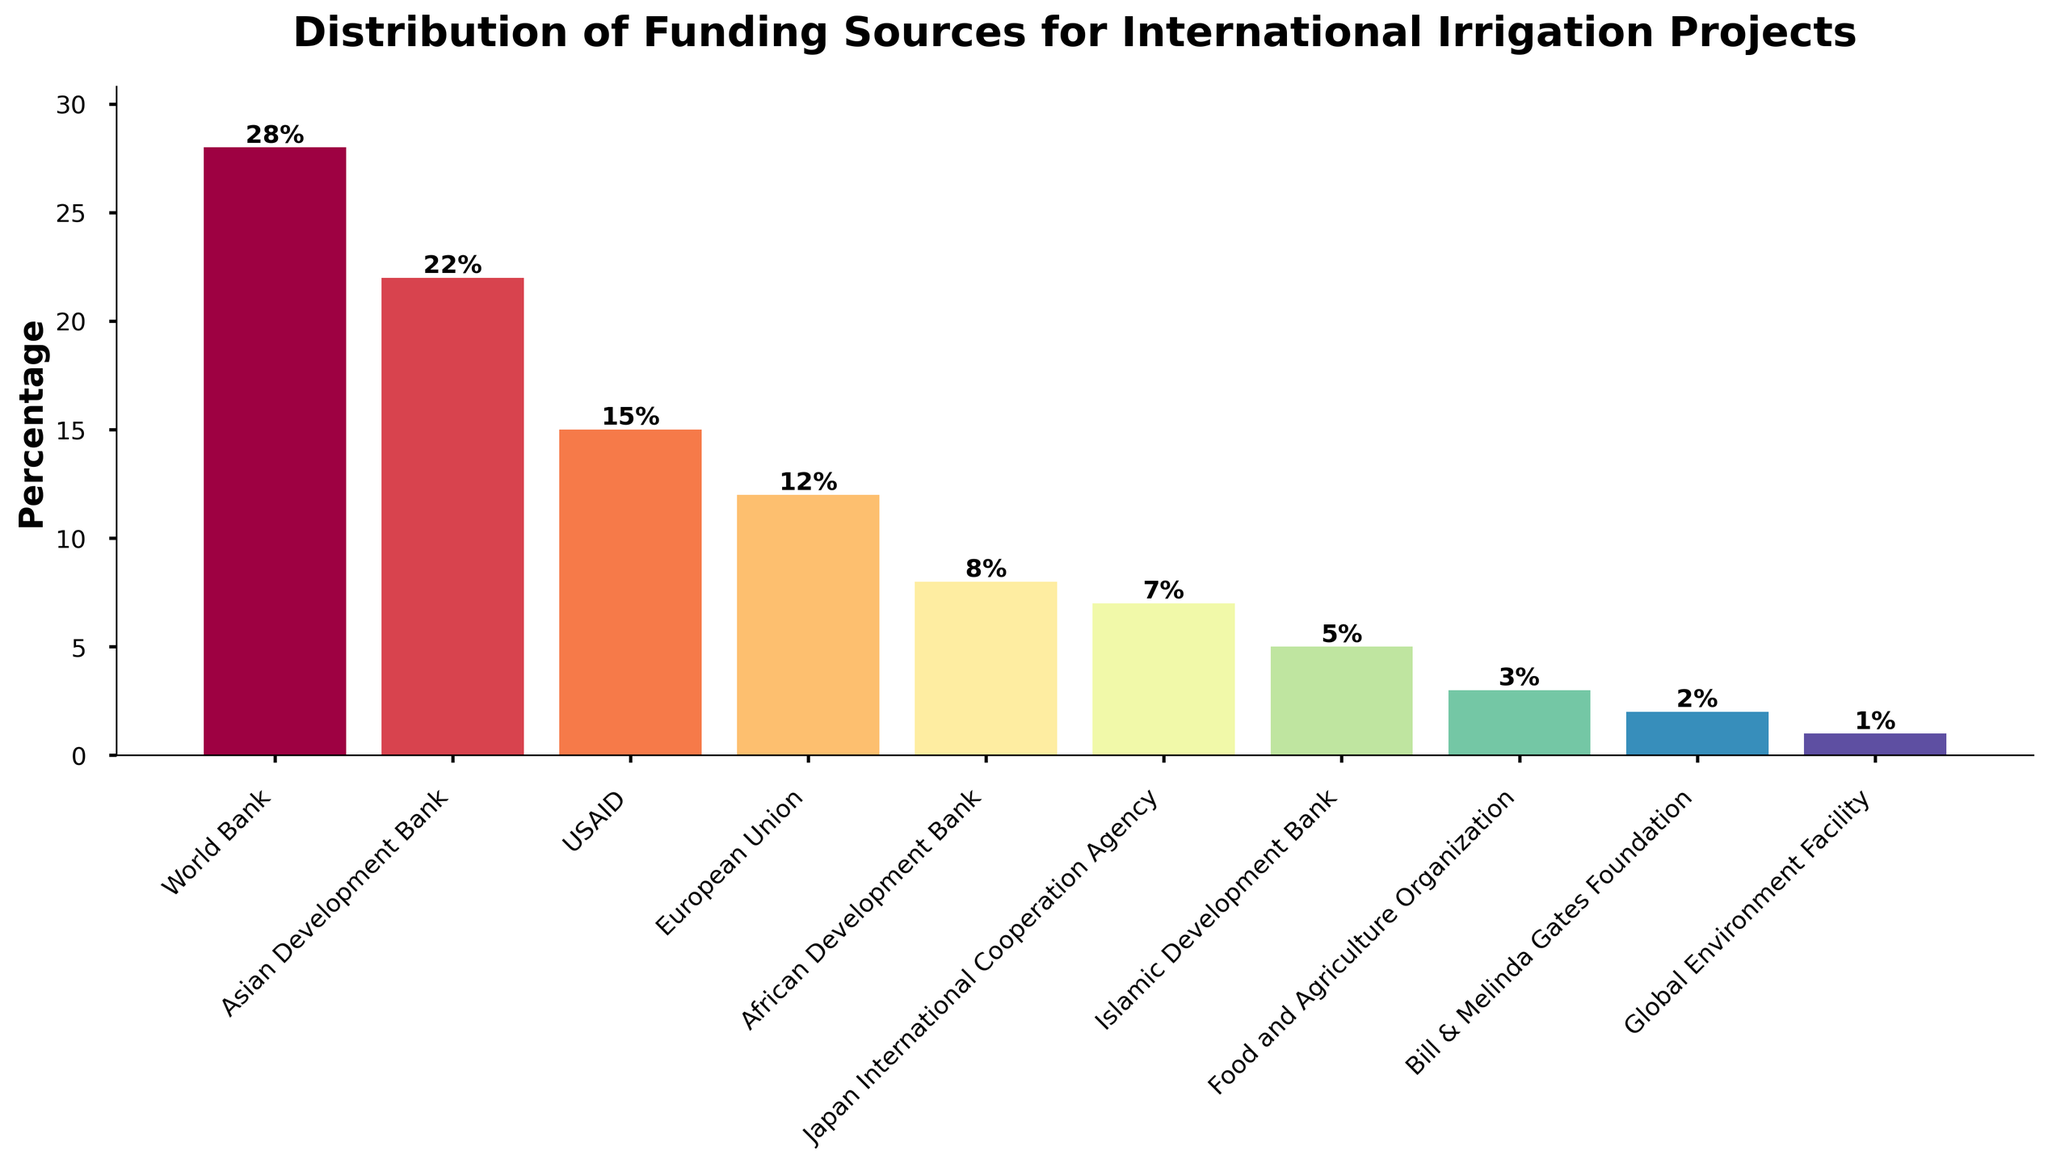What is the percentage of funding from the World Bank? The bar chart shows the percentage of each funding source. The World Bank's bar reaches 28 on the y-axis, indicating it contributes 28% of the funding.
Answer: 28% Which two funding sources contribute the least and how much do they contribute together? The bars representing the Global Environment Facility and the Bill & Melinda Gates Foundation have the shortest heights, indicating 1% and 2% respectively. Adding these together: 1% + 2% = 3%.
Answer: Global Environment Facility and Bill & Melinda Gates Foundation; 3% How much more does the Asian Development Bank contribute compared to the African Development Bank? The Asian Development Bank contributes 22% while the African Development Bank contributes 8%. Subtracting these gives: 22% - 8% = 14%.
Answer: 14% Which funding source contributes more: USAID or Japan International Cooperation Agency, and by how much? USAID's bar is at 15% and Japan International Cooperation Agency's bar is at 7%. Subtracting these gives: 15% - 7% = 8%.
Answer: USAID by 8% If you sum the contributions from USAID and the European Union, what is the total percentage? According to the bar chart, USAID contributes 15% and the European Union contributes 12%. Adding these together: 15% + 12% = 27%.
Answer: 27% What is the range of the percentages contributed by the different funding sources? The highest percentage is from the World Bank at 28%, and the lowest is from the Global Environment Facility at 1%. The range is calculated as: 28% - 1% = 27%.
Answer: 27% What is the combined percentage of funding from sources contributing less than 10% each? The funding sources with contributions less than 10% are African Development Bank (8%), Japan International Cooperation Agency (7%), Islamic Development Bank (5%), Food and Agriculture Organization (3%), Bill & Melinda Gates Foundation (2%), and Global Environment Facility (1%). Summing these gives: 8% + 7% + 5% + 3% + 2% + 1% = 26%.
Answer: 26% Which funding source is represented by the tallest bar? The tallest bar in the chart is labeled "World Bank" with a height of 28.
Answer: World Bank How does the height of the USAID bar compare to that of the European Union bar? The USAID bar is slightly taller than the European Union bar. USAID is at 15% while the European Union is at 12%.
Answer: USAID is taller by 3% What percentage of the total funding is contributed by non-bank entities (excluding World Bank, Asian Development Bank, and African Development Bank)? The non-bank entities are USAID (15%), European Union (12%), Japan International Cooperation Agency (7%), Islamic Development Bank (5%), Food and Agriculture Organization (3%), Bill & Melinda Gates Foundation (2%), and Global Environment Facility (1%). Summing these gives: 15% + 12% + 7% + 5% + 3% + 2% + 1% = 45%.
Answer: 45% 